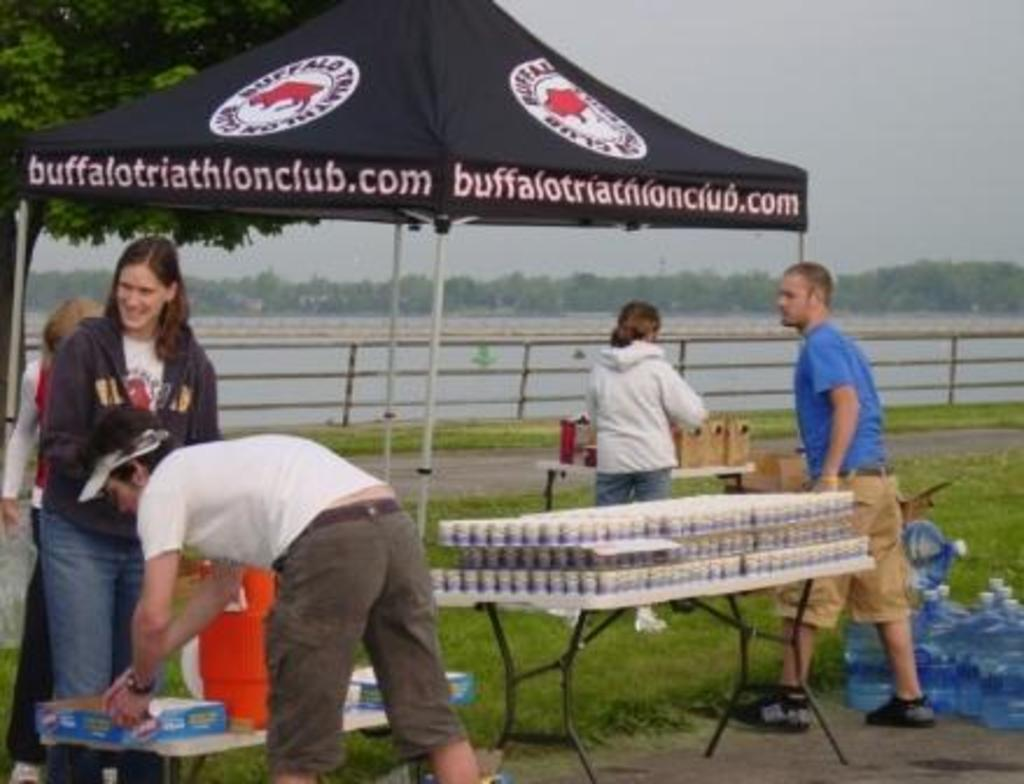How many people are in the group visible in the image? There is a group of people standing in the image, but the exact number cannot be determined from the provided facts. What is on the table in the image? There are bottles on a table in the image. What can be seen in the background of the image? In the background of the image, there is a tent, railing, water, a tree, and the sky. What might the people in the group be doing? It is not clear from the provided facts what the people in the group are doing. Can you describe the setting of the image? The image appears to be outdoors, with a tent, railing, water, a tree, and the sky visible in the background. How many goats are visible in the image? There are no goats present in the image. What type of drink is being consumed by the people in the image? The provided facts do not mention any drinks being consumed by the people in the image. 